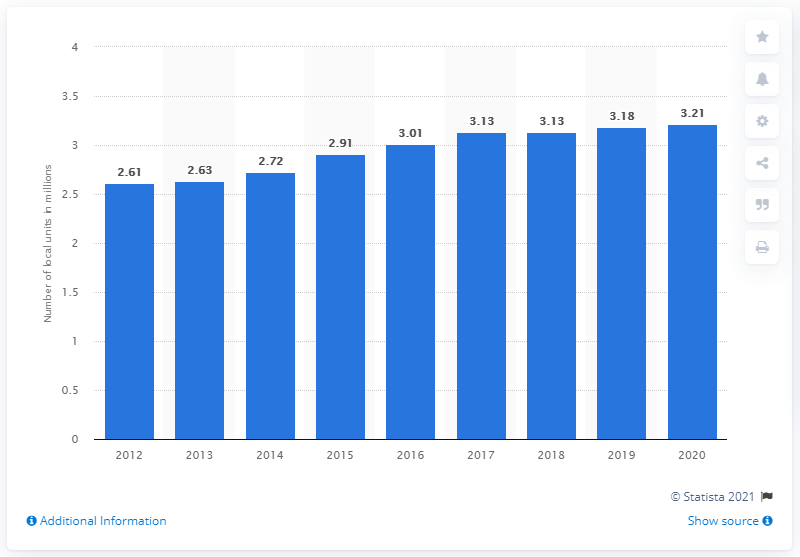Point out several critical features in this image. In the year 2020, there were approximately 3.18 million business sites in the United Kingdom. 